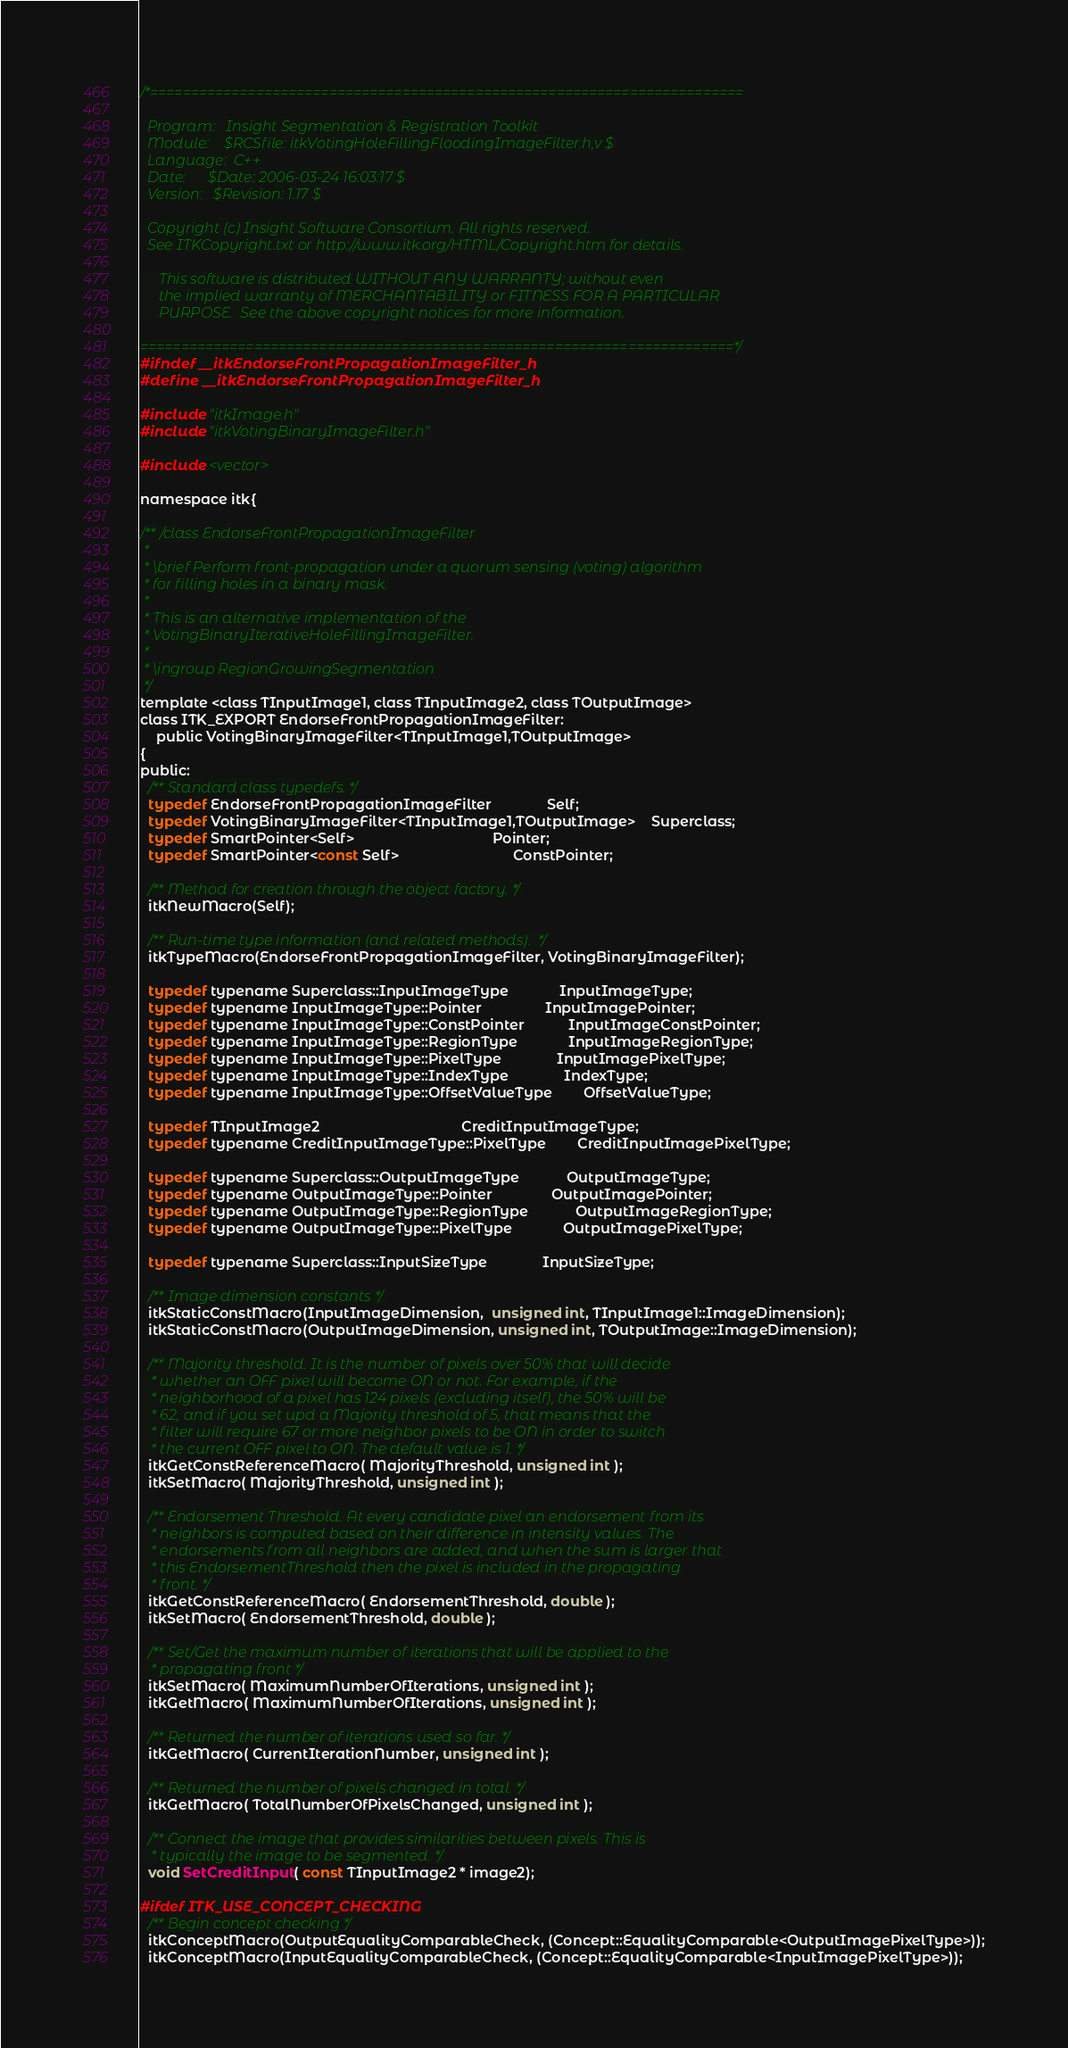Convert code to text. <code><loc_0><loc_0><loc_500><loc_500><_C_>/*=========================================================================

  Program:   Insight Segmentation & Registration Toolkit
  Module:    $RCSfile: itkVotingHoleFillingFloodingImageFilter.h,v $
  Language:  C++
  Date:      $Date: 2006-03-24 16:03:17 $
  Version:   $Revision: 1.17 $

  Copyright (c) Insight Software Consortium. All rights reserved.
  See ITKCopyright.txt or http://www.itk.org/HTML/Copyright.htm for details.

     This software is distributed WITHOUT ANY WARRANTY; without even 
     the implied warranty of MERCHANTABILITY or FITNESS FOR A PARTICULAR 
     PURPOSE.  See the above copyright notices for more information.

=========================================================================*/
#ifndef __itkEndorseFrontPropagationImageFilter_h
#define __itkEndorseFrontPropagationImageFilter_h

#include "itkImage.h"
#include "itkVotingBinaryImageFilter.h"

#include <vector>

namespace itk{

/** /class EndorseFrontPropagationImageFilter 
 *
 * \brief Perform front-propagation under a quorum sensing (voting) algorithm
 * for filling holes in a binary mask.
 * 
 * This is an alternative implementation of the
 * VotingBinaryIterativeHoleFillingImageFilter.
 *
 * \ingroup RegionGrowingSegmentation 
 */
template <class TInputImage1, class TInputImage2, class TOutputImage>
class ITK_EXPORT EndorseFrontPropagationImageFilter:
    public VotingBinaryImageFilter<TInputImage1,TOutputImage>
{
public:
  /** Standard class typedefs. */
  typedef EndorseFrontPropagationImageFilter              Self;
  typedef VotingBinaryImageFilter<TInputImage1,TOutputImage>    Superclass;
  typedef SmartPointer<Self>                                   Pointer;
  typedef SmartPointer<const Self>                             ConstPointer;

  /** Method for creation through the object factory. */
  itkNewMacro(Self);

  /** Run-time type information (and related methods).  */
  itkTypeMacro(EndorseFrontPropagationImageFilter, VotingBinaryImageFilter);

  typedef typename Superclass::InputImageType             InputImageType;
  typedef typename InputImageType::Pointer                InputImagePointer;
  typedef typename InputImageType::ConstPointer           InputImageConstPointer;
  typedef typename InputImageType::RegionType             InputImageRegionType; 
  typedef typename InputImageType::PixelType              InputImagePixelType; 
  typedef typename InputImageType::IndexType              IndexType;
  typedef typename InputImageType::OffsetValueType        OffsetValueType;
  
  typedef TInputImage2                                    CreditInputImageType;
  typedef typename CreditInputImageType::PixelType        CreditInputImagePixelType; 

  typedef typename Superclass::OutputImageType            OutputImageType;
  typedef typename OutputImageType::Pointer               OutputImagePointer;
  typedef typename OutputImageType::RegionType            OutputImageRegionType; 
  typedef typename OutputImageType::PixelType             OutputImagePixelType; 
  
  typedef typename Superclass::InputSizeType              InputSizeType;
  
  /** Image dimension constants */
  itkStaticConstMacro(InputImageDimension,  unsigned int, TInputImage1::ImageDimension);
  itkStaticConstMacro(OutputImageDimension, unsigned int, TOutputImage::ImageDimension);

  /** Majority threshold. It is the number of pixels over 50% that will decide
   * whether an OFF pixel will become ON or not. For example, if the
   * neighborhood of a pixel has 124 pixels (excluding itself), the 50% will be
   * 62, and if you set upd a Majority threshold of 5, that means that the
   * filter will require 67 or more neighbor pixels to be ON in order to switch
   * the current OFF pixel to ON. The default value is 1. */ 
  itkGetConstReferenceMacro( MajorityThreshold, unsigned int );
  itkSetMacro( MajorityThreshold, unsigned int );

  /** Endorsement Threshold. At every candidate pixel an endorsement from its
   * neighbors is computed based on their difference in intensity values. The
   * endorsements from all neighbors are added, and when the sum is larger that
   * this EndorsementThreshold then the pixel is included in the propagating
   * front. */
  itkGetConstReferenceMacro( EndorsementThreshold, double );
  itkSetMacro( EndorsementThreshold, double );

  /** Set/Get the maximum number of iterations that will be applied to the
   * propagating front */
  itkSetMacro( MaximumNumberOfIterations, unsigned int );
  itkGetMacro( MaximumNumberOfIterations, unsigned int );

  /** Returned the number of iterations used so far. */
  itkGetMacro( CurrentIterationNumber, unsigned int );

  /** Returned the number of pixels changed in total. */
  itkGetMacro( TotalNumberOfPixelsChanged, unsigned int );

  /** Connect the image that provides similarities between pixels. This is
   * typically the image to be segmented. */
  void SetCreditInput( const TInputImage2 * image2);

#ifdef ITK_USE_CONCEPT_CHECKING
  /** Begin concept checking */
  itkConceptMacro(OutputEqualityComparableCheck, (Concept::EqualityComparable<OutputImagePixelType>));
  itkConceptMacro(InputEqualityComparableCheck, (Concept::EqualityComparable<InputImagePixelType>));</code> 